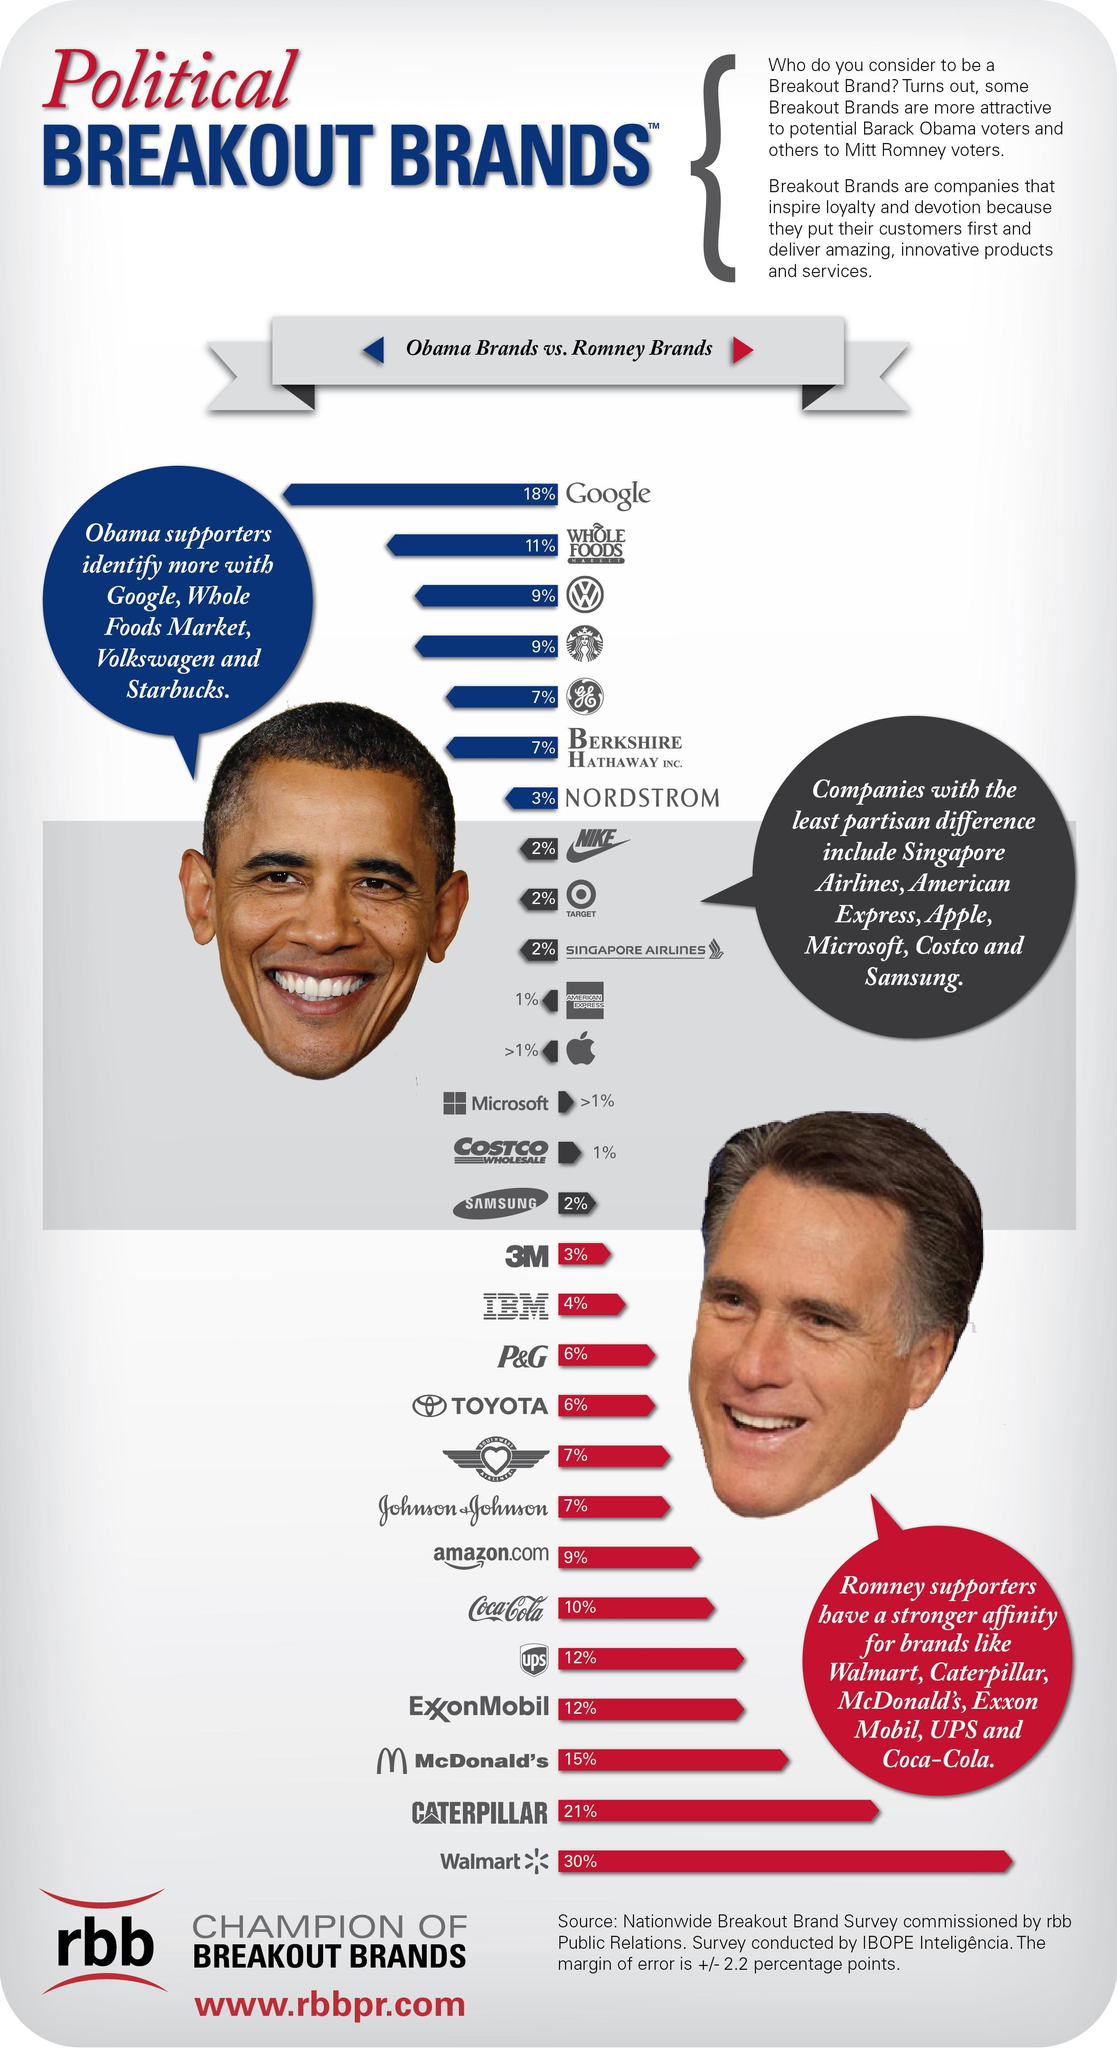whose picture is given at the left side of the infographic?
Answer the question with a short phrase. Obama whose picture is given at the right side of the infographic? Mitt Romney 